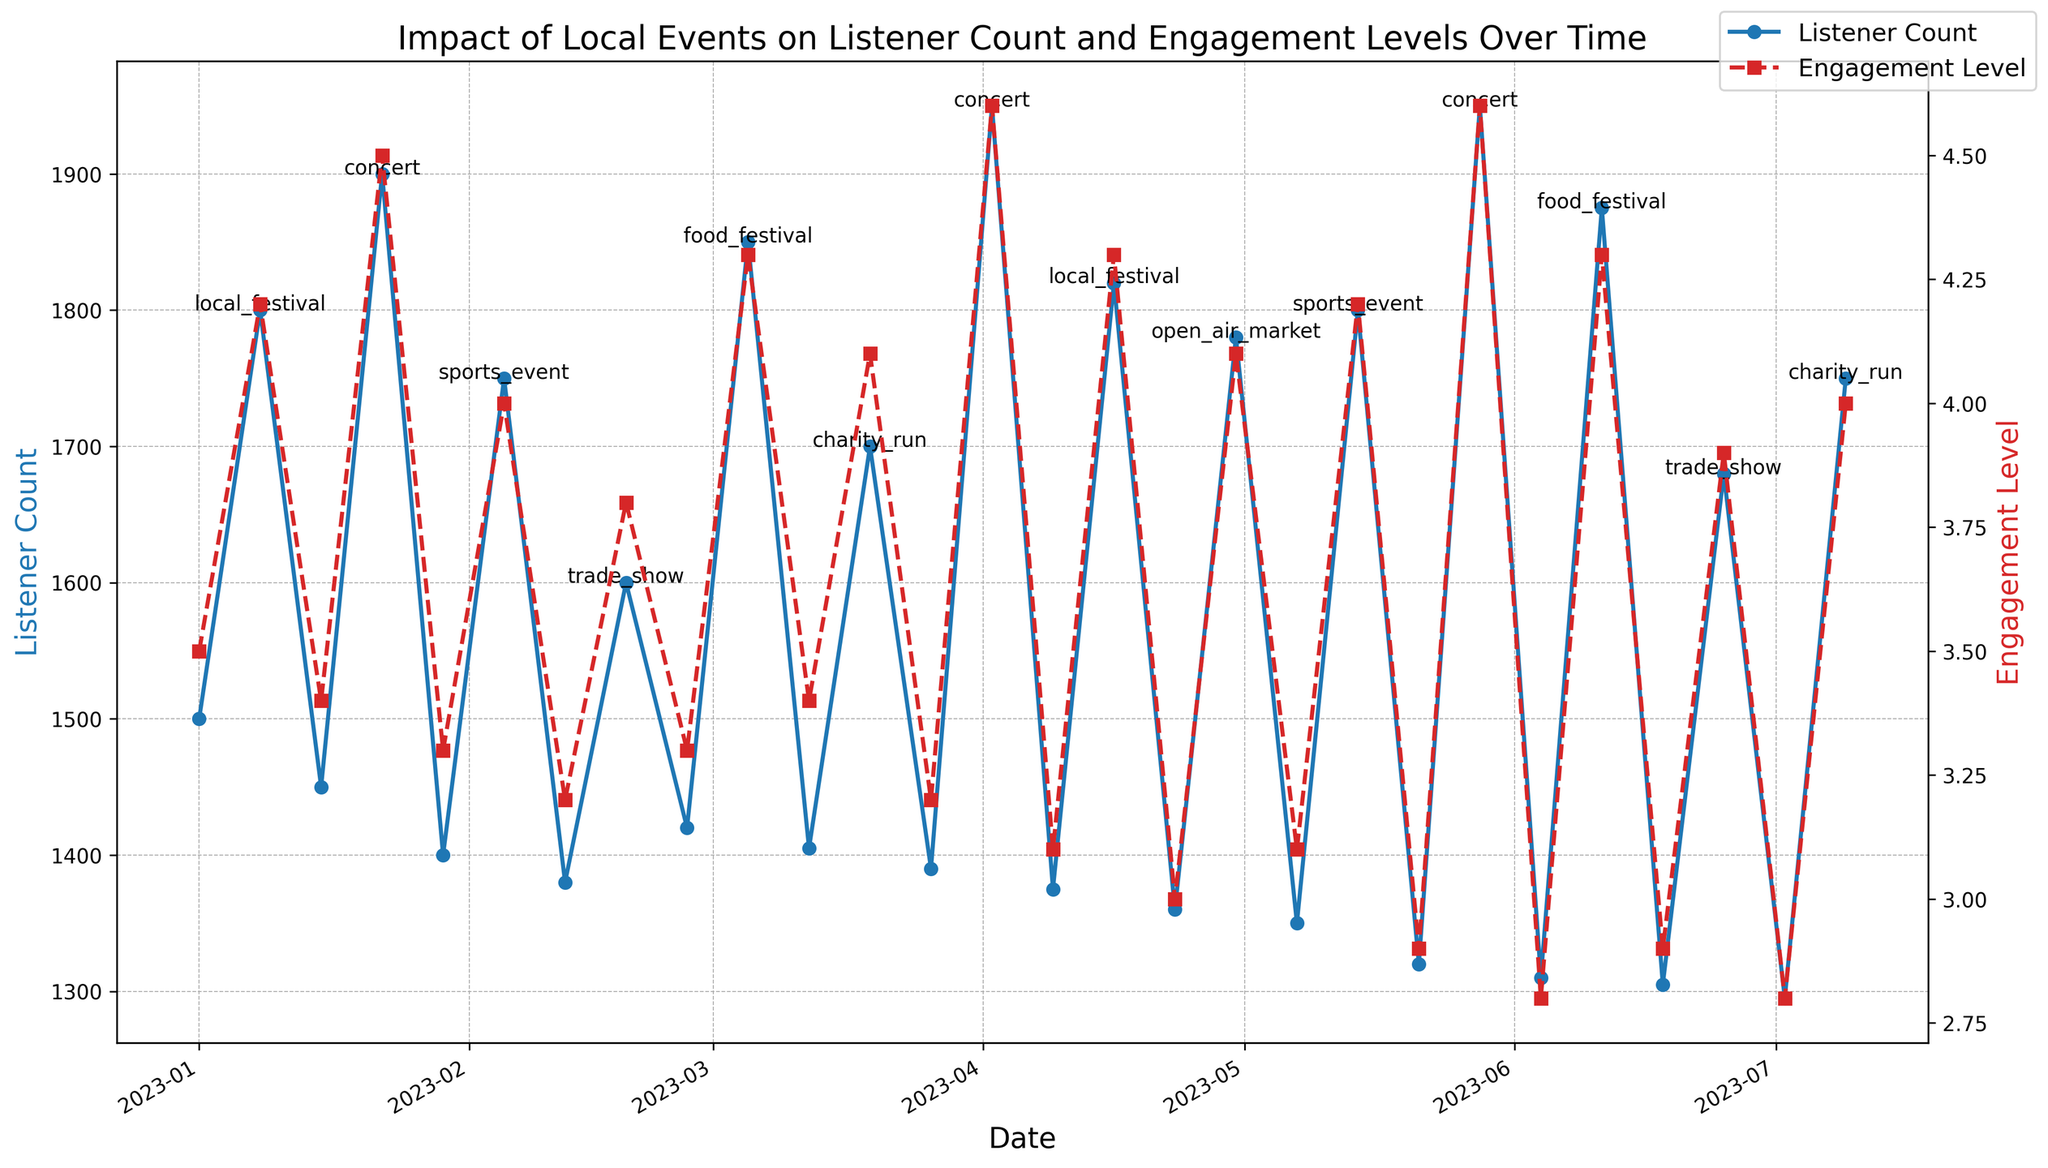What date had the highest listener count? The highest listener count can be identified by looking for the peak point on the blue line. It occurs on 2023-04-02 during a concert with 1950 listeners.
Answer: 2023-04-02 How many days showed listener counts above 1800? To find the days with listener counts above 1800, look for points above the 1800 mark on the blue line. These dates are 2023-01-08, 2023-01-22, 2023-03-05, 2023-04-02, 2023-04-16, 2023-05-14, 2023-05-28, and 2023-06-11. The total is 8 days.
Answer: 8 Which event had the highest engagement level and what was it? The highest engagement level can be identified by looking at the red line for the highest point, which corresponds to 2023-04-02, during a concert, with an engagement level of 4.6.
Answer: Concert with 4.6 What are the average listener counts for dates with and without events? Average listener count with events: (1800+1900+1750+1600+1850+1700+1950+1820+1780+1800+1950+1875+1680+1750)/14 = 1814.3. Average listener count without events: (1500+1450+1400+1380+1420+1405+1390+1375+1360+1350+1320+1310+1305+1295)/14 = 1383.9.
Answer: With events: 1814.3, Without events: 1383.9 What is the difference in engagement levels between 2023-01-08 and 2023-04-09? Engagement level on 2023-01-08 is 4.2, and on 2023-04-09 is 3.1. The difference is 4.2 - 3.1 = 1.1.
Answer: 1.1 What color represents the engagement level line in the plot? The engagement level line is represented by the red color, easily distinguishable in the graph.
Answer: Red Which event caused the largest increase in listener count compared to the previous week? Compare the increase in listener counts preceding each event. The largest increase is observed before the concert on 2023-04-02: 1950 - 1390 = 560.
Answer: Concert (2023-04-02) by 560 Which non-event date had the lowest engagement level? Identify the lowest point on the red line corresponding to non-event dates. The lowest engagement level is 2.8 on 2023-06-04 and 2023-07-02.
Answer: 2023-06-04 and 2023-07-02 What is the trend in listener counts following event dates? Inspect the blue line after event dates. Generally, the listener counts decrease following high peaks seen in events such as concerts and festivals, returning to lower values on non-event weeks.
Answer: Generally decreases Which event date had the lowest engagement level, and what was it? The lowest engagement level on an event date is 3.8 on 2023-02-19 during a trade show.
Answer: Trade show with 3.8 